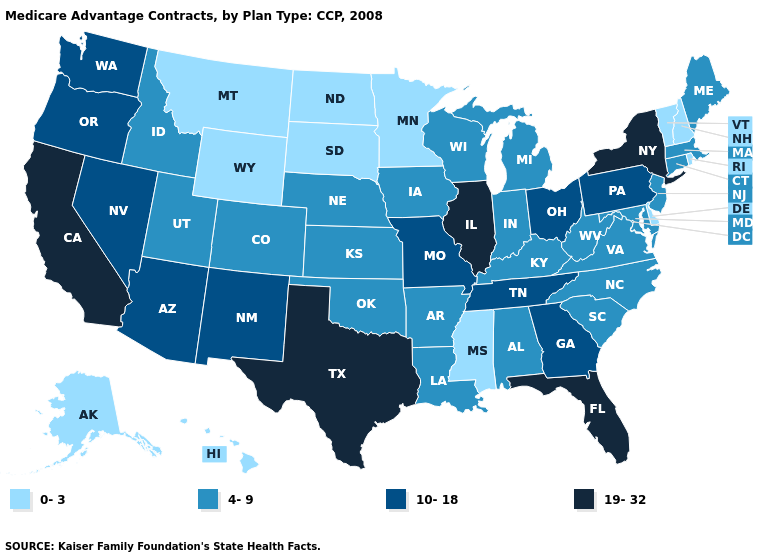Does Oregon have the highest value in the USA?
Short answer required. No. Does Iowa have a higher value than New Hampshire?
Answer briefly. Yes. What is the value of South Dakota?
Give a very brief answer. 0-3. What is the value of New York?
Quick response, please. 19-32. Does the map have missing data?
Write a very short answer. No. Among the states that border Alabama , does Florida have the highest value?
Be succinct. Yes. Name the states that have a value in the range 19-32?
Write a very short answer. California, Florida, Illinois, New York, Texas. How many symbols are there in the legend?
Write a very short answer. 4. Which states have the highest value in the USA?
Keep it brief. California, Florida, Illinois, New York, Texas. Which states hav the highest value in the West?
Be succinct. California. Which states have the lowest value in the MidWest?
Be succinct. Minnesota, North Dakota, South Dakota. What is the value of Pennsylvania?
Short answer required. 10-18. Name the states that have a value in the range 4-9?
Be succinct. Alabama, Arkansas, Colorado, Connecticut, Iowa, Idaho, Indiana, Kansas, Kentucky, Louisiana, Massachusetts, Maryland, Maine, Michigan, North Carolina, Nebraska, New Jersey, Oklahoma, South Carolina, Utah, Virginia, Wisconsin, West Virginia. Which states have the highest value in the USA?
Concise answer only. California, Florida, Illinois, New York, Texas. Name the states that have a value in the range 19-32?
Answer briefly. California, Florida, Illinois, New York, Texas. 